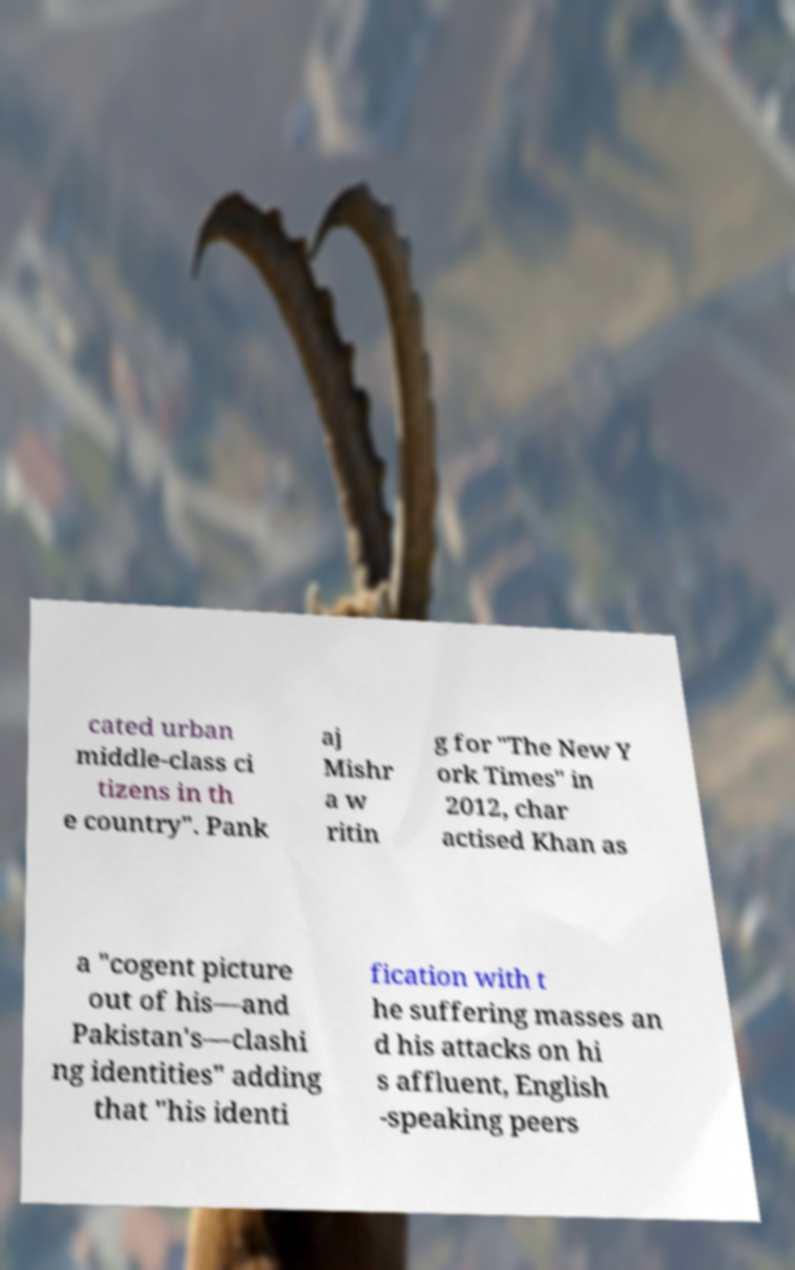Please identify and transcribe the text found in this image. cated urban middle-class ci tizens in th e country". Pank aj Mishr a w ritin g for "The New Y ork Times" in 2012, char actised Khan as a "cogent picture out of his—and Pakistan's—clashi ng identities" adding that "his identi fication with t he suffering masses an d his attacks on hi s affluent, English -speaking peers 